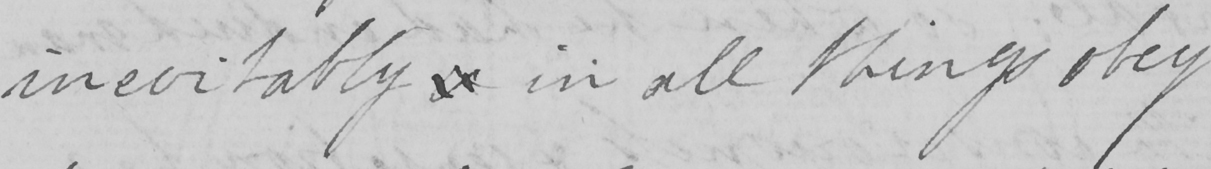Please transcribe the handwritten text in this image. inevitably  &  in all things obey 